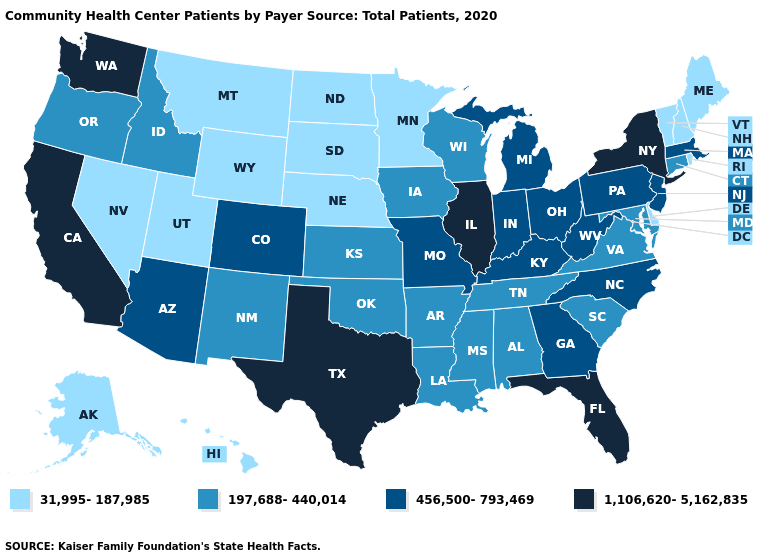Does Mississippi have the same value as Maryland?
Concise answer only. Yes. Does Michigan have the lowest value in the MidWest?
Be succinct. No. Which states hav the highest value in the Northeast?
Be succinct. New York. Which states have the lowest value in the Northeast?
Give a very brief answer. Maine, New Hampshire, Rhode Island, Vermont. What is the highest value in states that border Alabama?
Concise answer only. 1,106,620-5,162,835. What is the lowest value in the USA?
Short answer required. 31,995-187,985. What is the value of New Hampshire?
Be succinct. 31,995-187,985. Among the states that border Nebraska , which have the lowest value?
Give a very brief answer. South Dakota, Wyoming. Name the states that have a value in the range 197,688-440,014?
Write a very short answer. Alabama, Arkansas, Connecticut, Idaho, Iowa, Kansas, Louisiana, Maryland, Mississippi, New Mexico, Oklahoma, Oregon, South Carolina, Tennessee, Virginia, Wisconsin. What is the value of Virginia?
Write a very short answer. 197,688-440,014. Name the states that have a value in the range 1,106,620-5,162,835?
Answer briefly. California, Florida, Illinois, New York, Texas, Washington. What is the lowest value in the USA?
Quick response, please. 31,995-187,985. Which states have the lowest value in the MidWest?
Answer briefly. Minnesota, Nebraska, North Dakota, South Dakota. Does Washington have the highest value in the USA?
Concise answer only. Yes. What is the value of Maryland?
Short answer required. 197,688-440,014. 